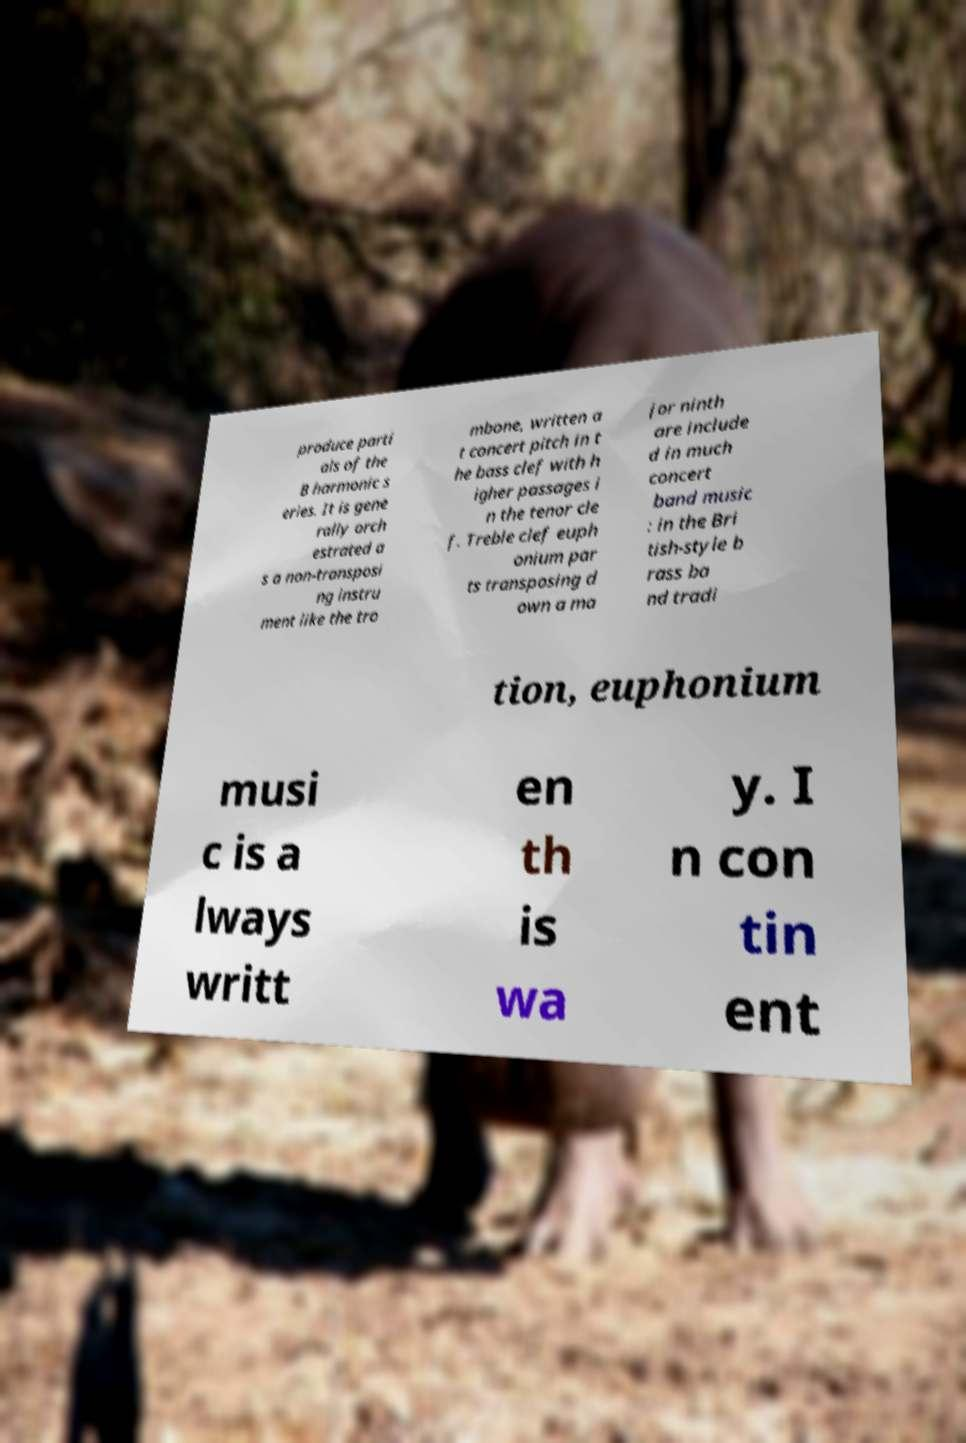There's text embedded in this image that I need extracted. Can you transcribe it verbatim? produce parti als of the B harmonic s eries. It is gene rally orch estrated a s a non-transposi ng instru ment like the tro mbone, written a t concert pitch in t he bass clef with h igher passages i n the tenor cle f. Treble clef euph onium par ts transposing d own a ma jor ninth are include d in much concert band music : in the Bri tish-style b rass ba nd tradi tion, euphonium musi c is a lways writt en th is wa y. I n con tin ent 